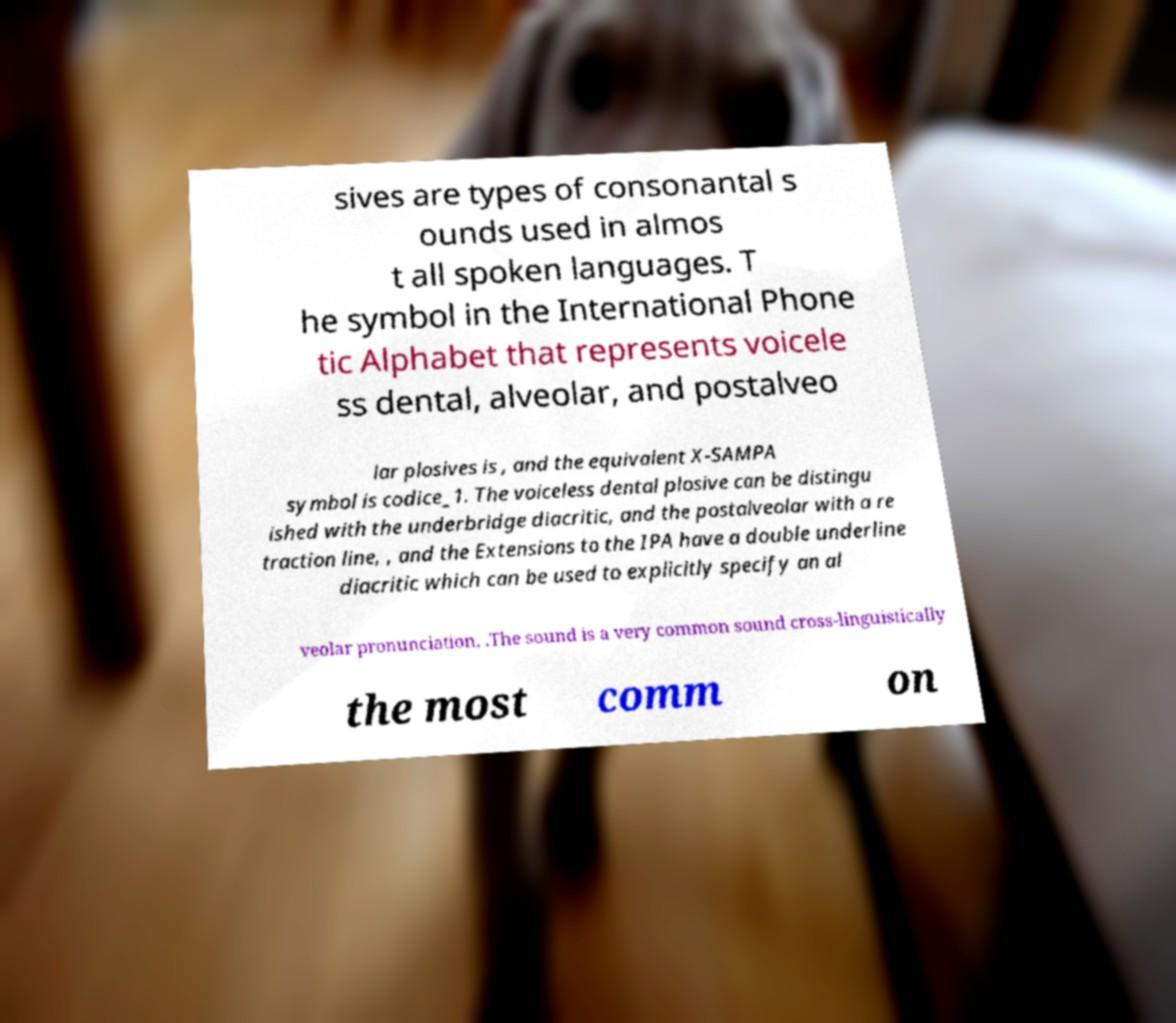Could you assist in decoding the text presented in this image and type it out clearly? sives are types of consonantal s ounds used in almos t all spoken languages. T he symbol in the International Phone tic Alphabet that represents voicele ss dental, alveolar, and postalveo lar plosives is , and the equivalent X-SAMPA symbol is codice_1. The voiceless dental plosive can be distingu ished with the underbridge diacritic, and the postalveolar with a re traction line, , and the Extensions to the IPA have a double underline diacritic which can be used to explicitly specify an al veolar pronunciation, .The sound is a very common sound cross-linguistically the most comm on 